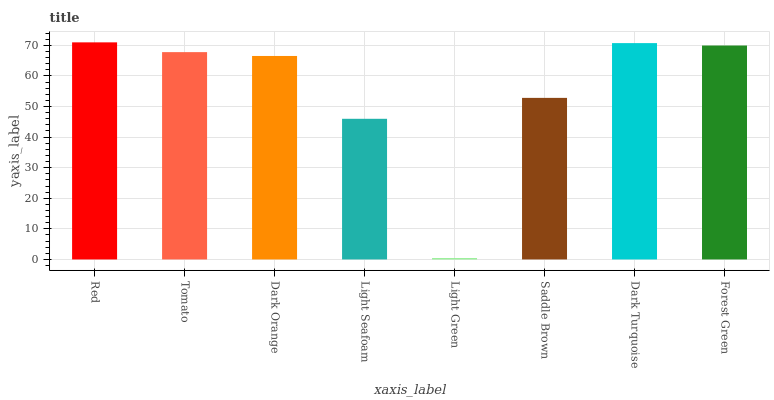Is Tomato the minimum?
Answer yes or no. No. Is Tomato the maximum?
Answer yes or no. No. Is Red greater than Tomato?
Answer yes or no. Yes. Is Tomato less than Red?
Answer yes or no. Yes. Is Tomato greater than Red?
Answer yes or no. No. Is Red less than Tomato?
Answer yes or no. No. Is Tomato the high median?
Answer yes or no. Yes. Is Dark Orange the low median?
Answer yes or no. Yes. Is Light Green the high median?
Answer yes or no. No. Is Light Green the low median?
Answer yes or no. No. 